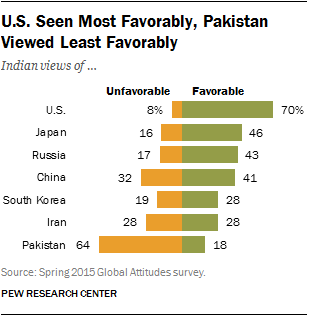Indicate a few pertinent items in this graphic. There are 7 countries depicted in the bar graph. The highest value and the lowest value were compared to determine the total percentage of favorable in the data set. The result of this comparison was 0.88. 